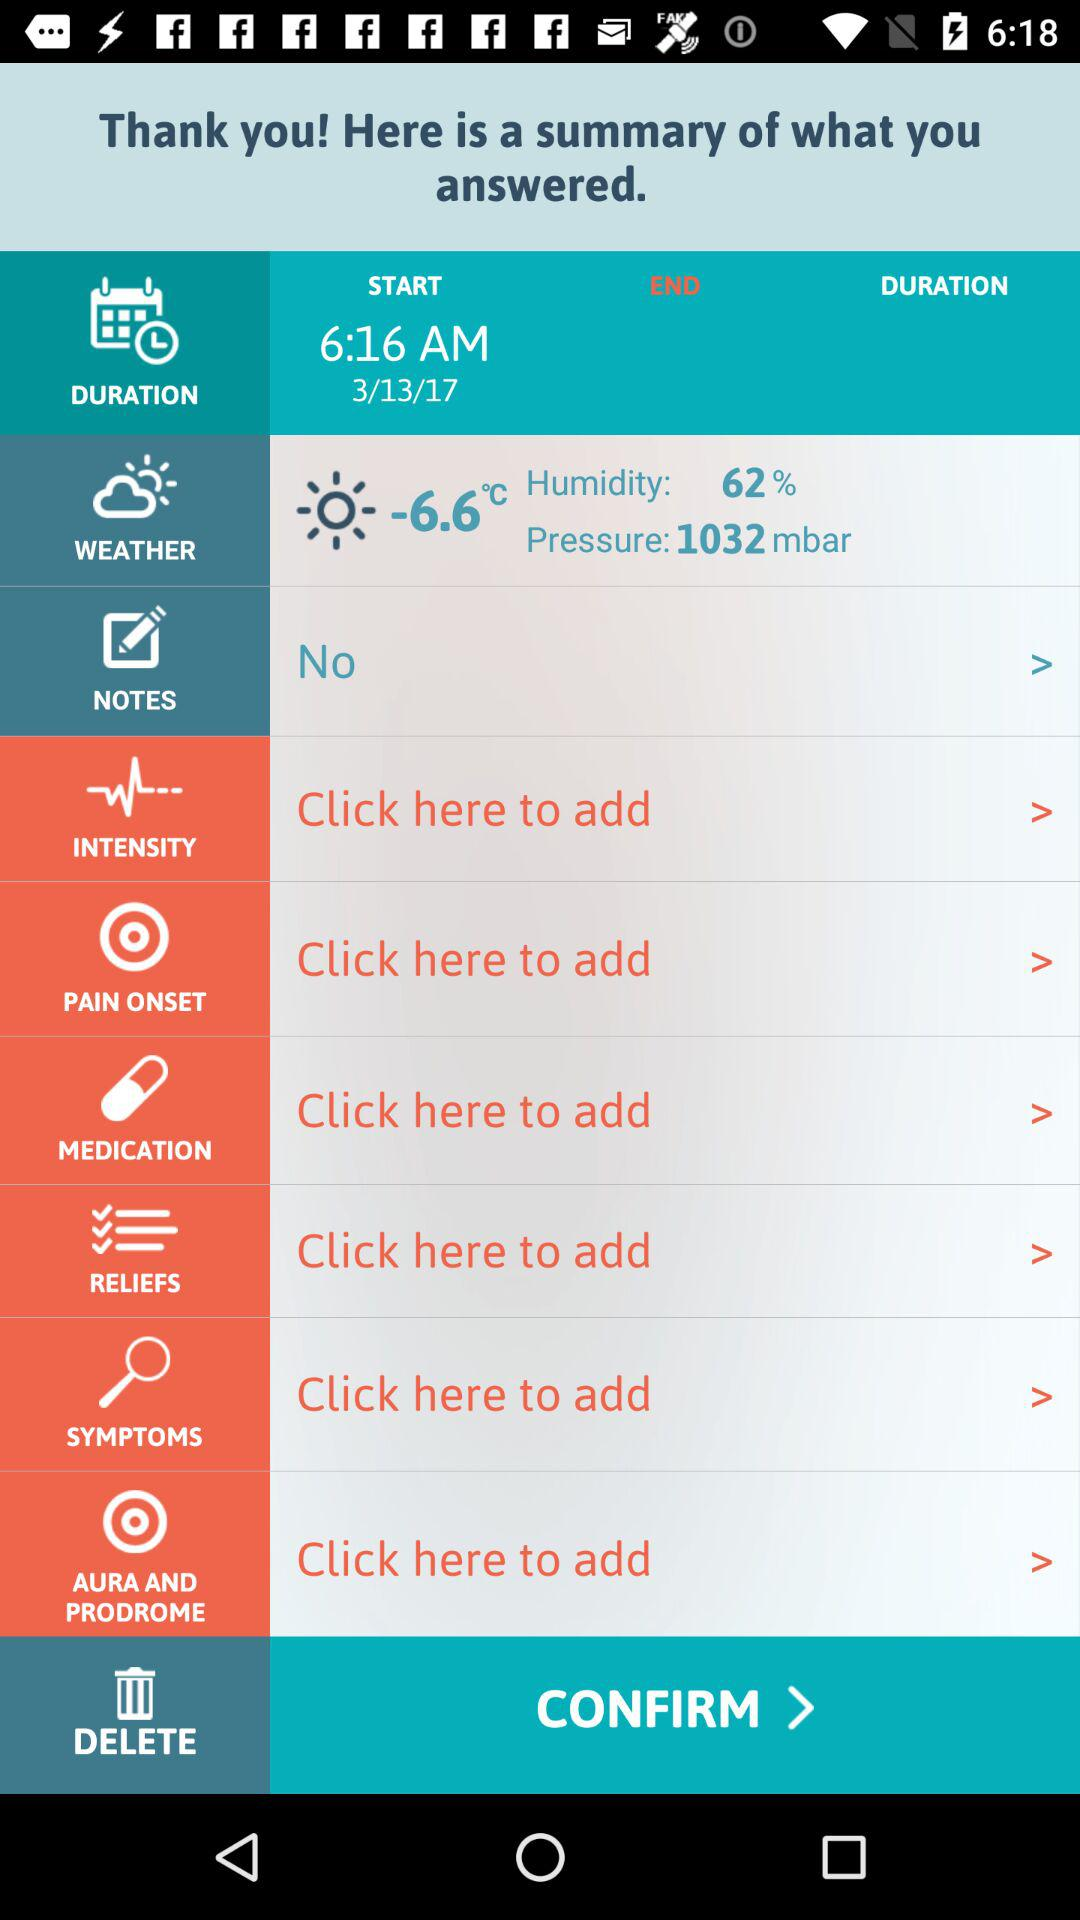What is the start time? The start time is 6:16 AM. 